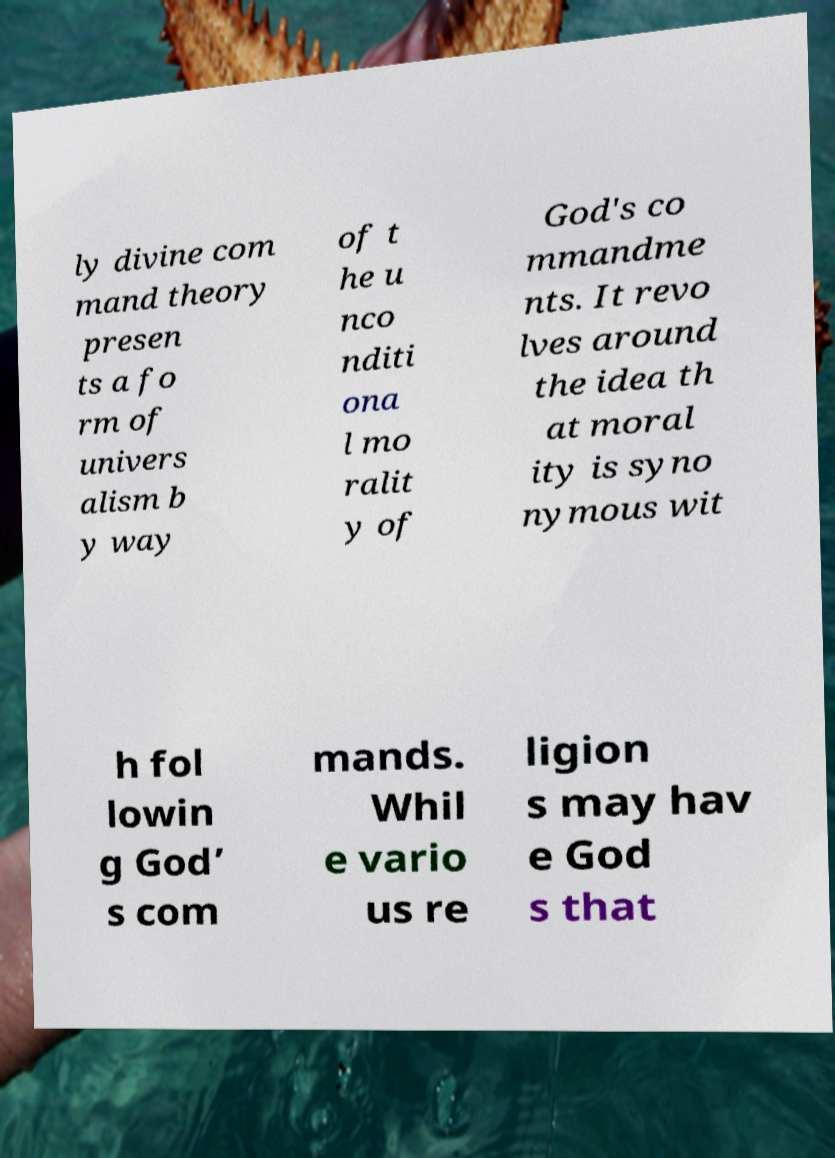Could you assist in decoding the text presented in this image and type it out clearly? ly divine com mand theory presen ts a fo rm of univers alism b y way of t he u nco nditi ona l mo ralit y of God's co mmandme nts. It revo lves around the idea th at moral ity is syno nymous wit h fol lowin g God’ s com mands. Whil e vario us re ligion s may hav e God s that 